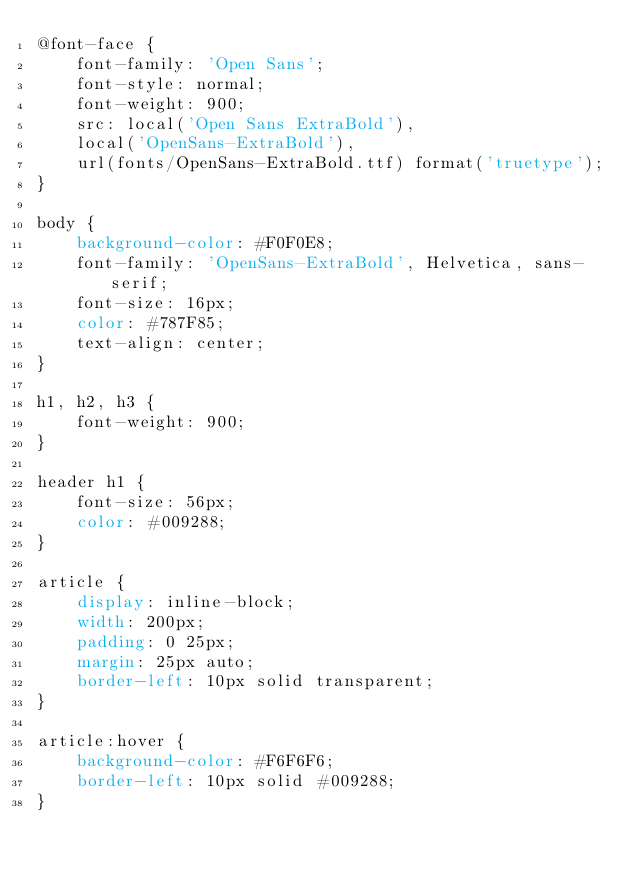Convert code to text. <code><loc_0><loc_0><loc_500><loc_500><_CSS_>@font-face {
    font-family: 'Open Sans';
    font-style: normal;
    font-weight: 900;
    src: local('Open Sans ExtraBold'),
    local('OpenSans-ExtraBold'),
    url(fonts/OpenSans-ExtraBold.ttf) format('truetype');
}

body {
    background-color: #F0F0E8;
    font-family: 'OpenSans-ExtraBold', Helvetica, sans-serif;
    font-size: 16px;
    color: #787F85;
    text-align: center;
}

h1, h2, h3 {
    font-weight: 900;
}

header h1 {
    font-size: 56px;
    color: #009288;
}

article {
    display: inline-block;
    width: 200px;
    padding: 0 25px;
    margin: 25px auto;
    border-left: 10px solid transparent;
}

article:hover {
    background-color: #F6F6F6;
    border-left: 10px solid #009288;
}</code> 